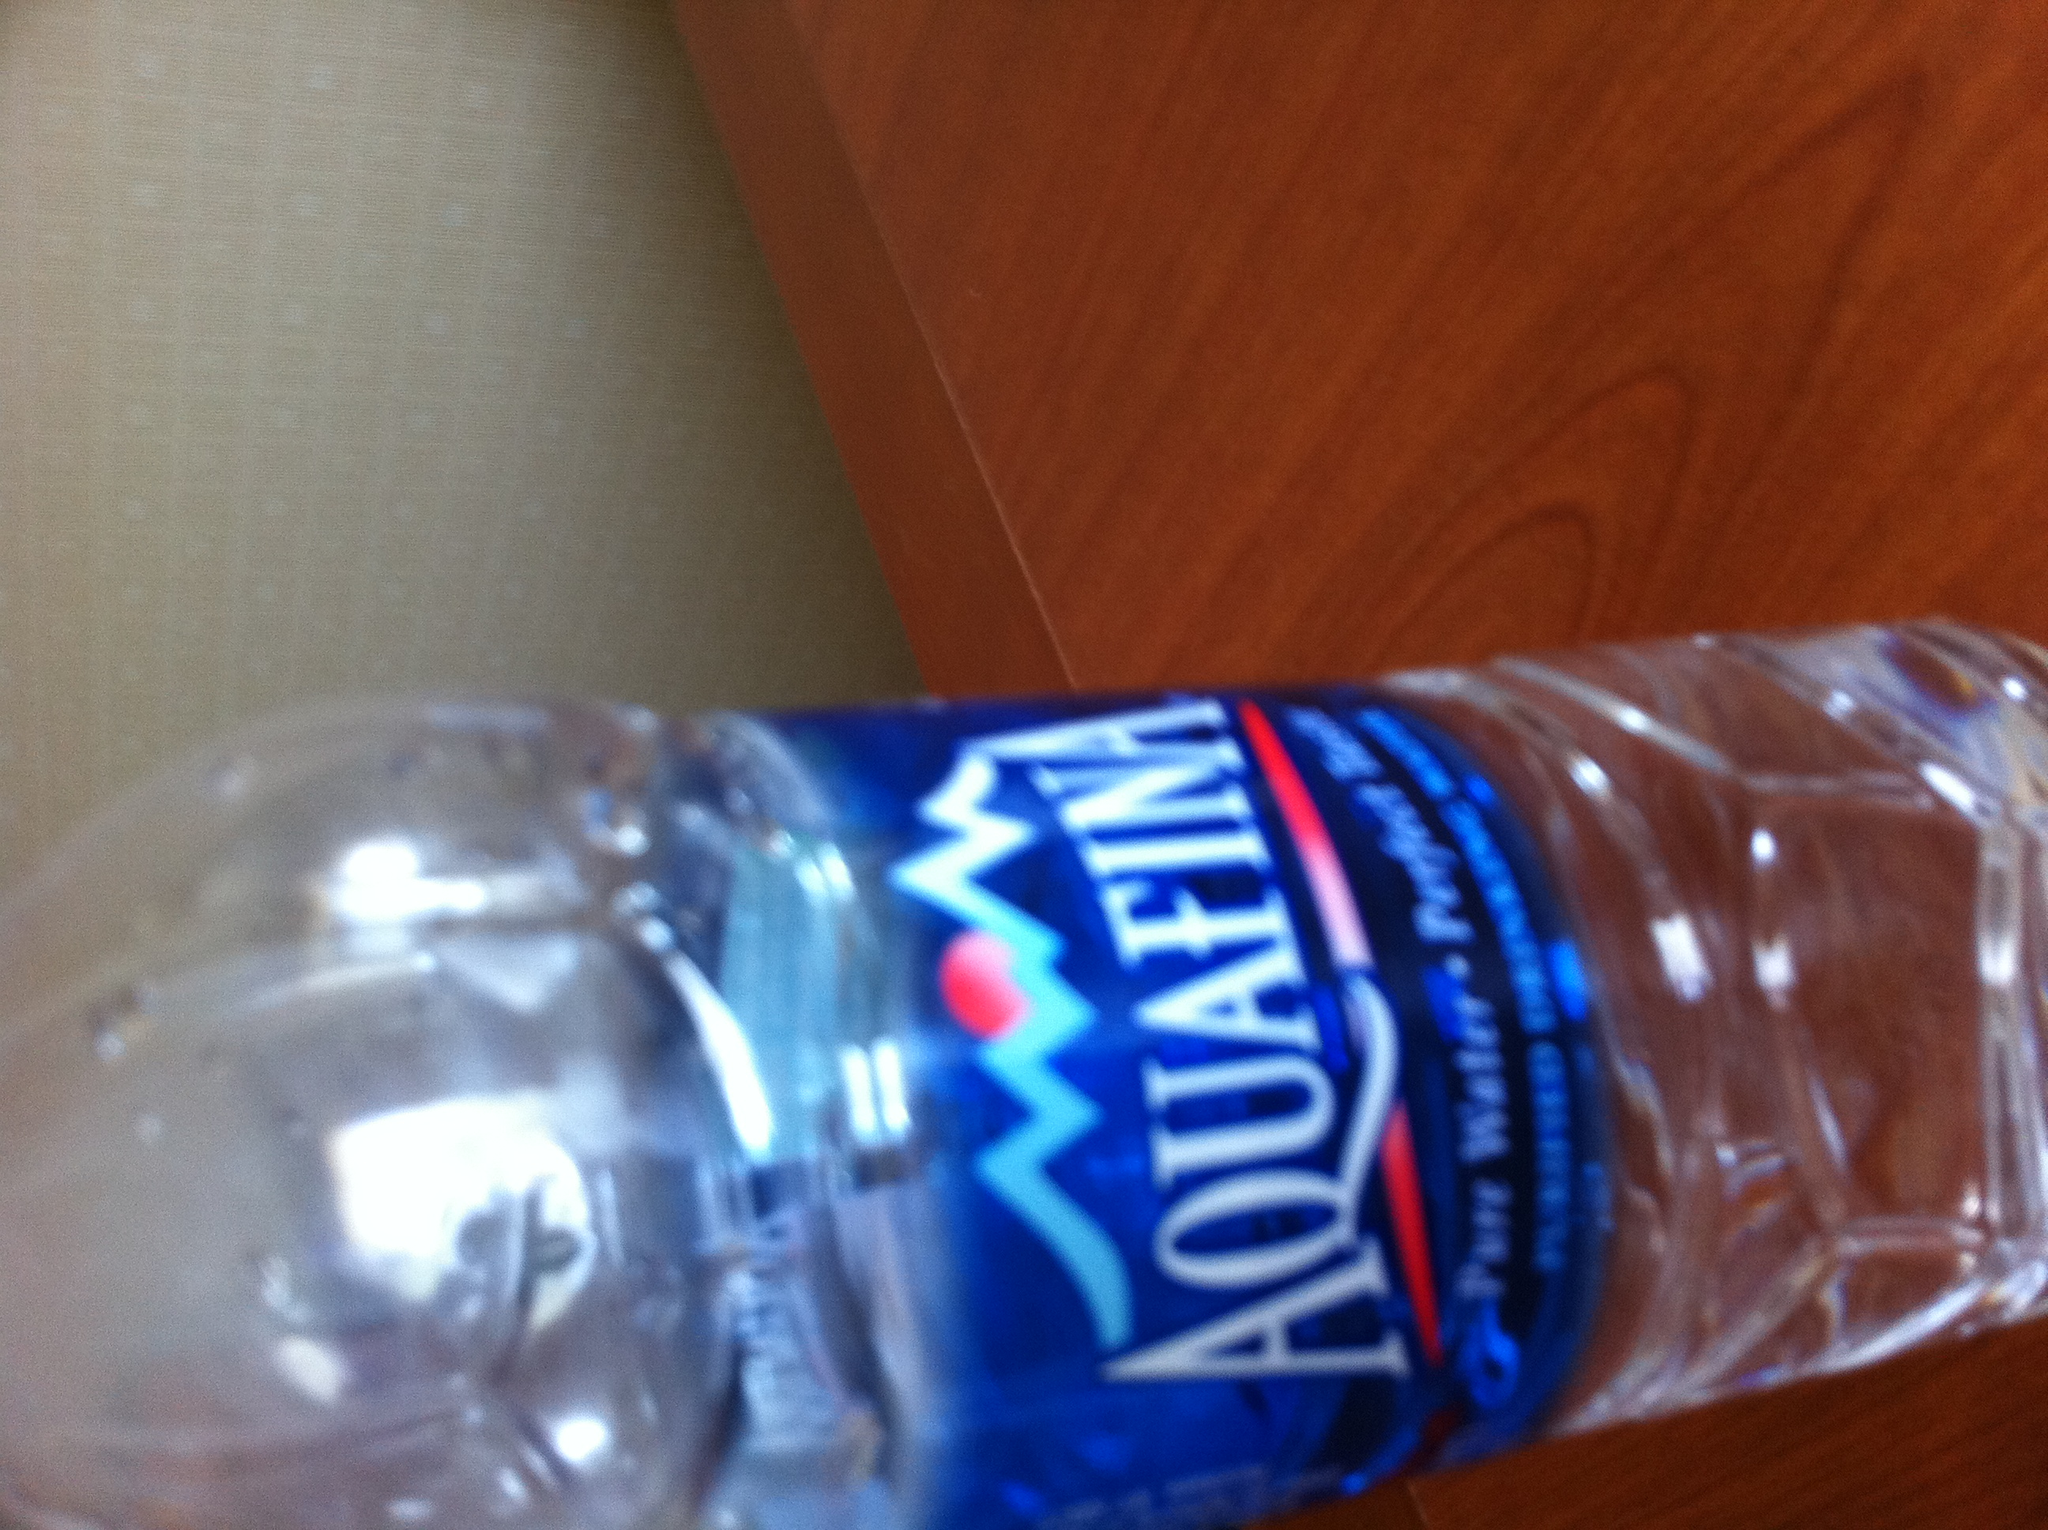Can you tell me if this water has minerals added for taste? Aquafina prides itself on its purity and does not add minerals for taste. Any minerals present are in trace amounts that occur naturally during the purification process. 